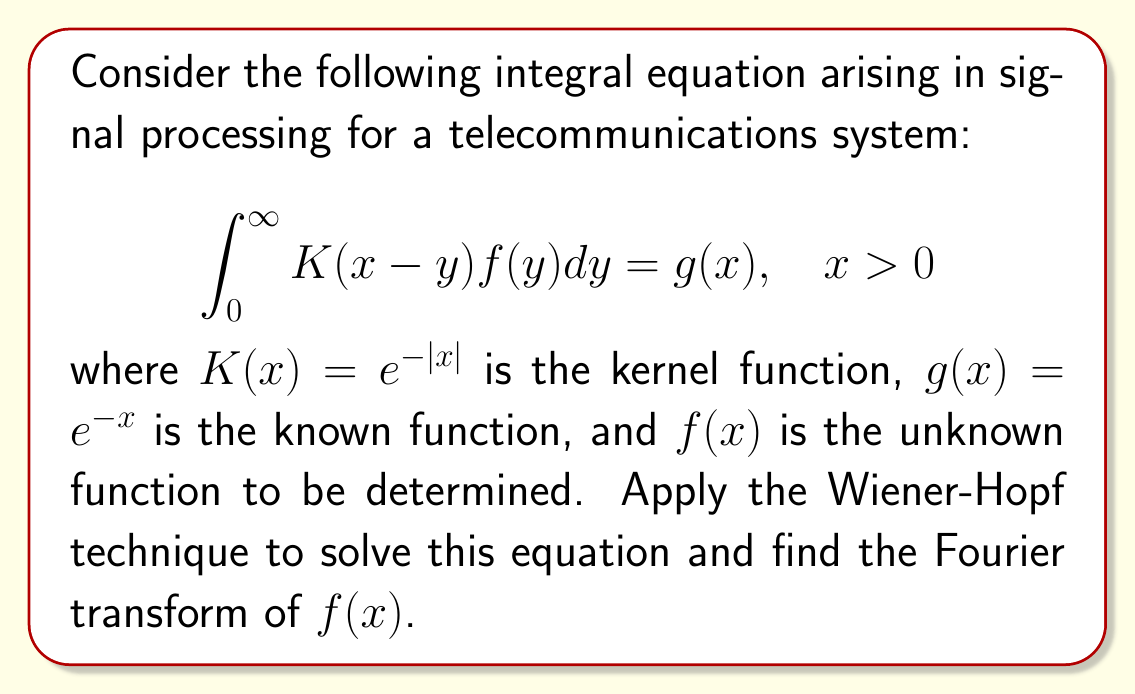Can you solve this math problem? Let's solve this problem step-by-step using the Wiener-Hopf technique:

1) First, extend the equation to the entire real line:
   $$\int_{-\infty}^{\infty} K(x-y)f_+(y)dy = g_+(x) + g_-(x), \quad -\infty < x < \infty$$
   where $f_+(x) = f(x)$ for $x > 0$ and 0 otherwise, $g_+(x) = g(x)$ for $x > 0$ and 0 otherwise, and $g_-(x)$ is an unknown function for $x < 0$.

2) Take the Fourier transform of both sides:
   $$\hat{K}(\omega)\hat{f}_+(\omega) = \hat{g}_+(\omega) + \hat{g}_-(\omega)$$

3) Calculate $\hat{K}(\omega)$:
   $$\hat{K}(\omega) = \int_{-\infty}^{\infty} e^{-|x|}e^{-i\omega x}dx = \frac{2}{1+\omega^2}$$

4) Calculate $\hat{g}_+(\omega)$:
   $$\hat{g}_+(\omega) = \int_{0}^{\infty} e^{-x}e^{-i\omega x}dx = \frac{1}{1+i\omega}$$

5) Substitute these into the equation:
   $$\frac{2}{1+\omega^2}\hat{f}_+(\omega) = \frac{1}{1+i\omega} + \hat{g}_-(\omega)$$

6) Factor the left side:
   $$\frac{2}{(1+i\omega)(1-i\omega)}\hat{f}_+(\omega) = \frac{1}{1+i\omega} + \hat{g}_-(\omega)$$

7) Rearrange:
   $$\frac{2\hat{f}_+(\omega)}{1-i\omega} = 1 + (1+i\omega)\hat{g}_-(\omega)$$

8) The left side is analytic in the upper half-plane, and the right side is analytic in the lower half-plane. By the Wiener-Hopf decomposition, both sides must equal a constant, say $C$:

   $$\frac{2\hat{f}_+(\omega)}{1-i\omega} = C = 1 + (1+i\omega)\hat{g}_-(\omega)$$

9) From the right equality, as $\omega \to -i\infty$, $\hat{g}_-(\omega) \to 0$, so $C = 1$.

10) Therefore, the solution for $\hat{f}_+(\omega)$ is:
    $$\hat{f}_+(\omega) = \frac{1-i\omega}{2}$$
Answer: $\hat{f}_+(\omega) = \frac{1-i\omega}{2}$ 